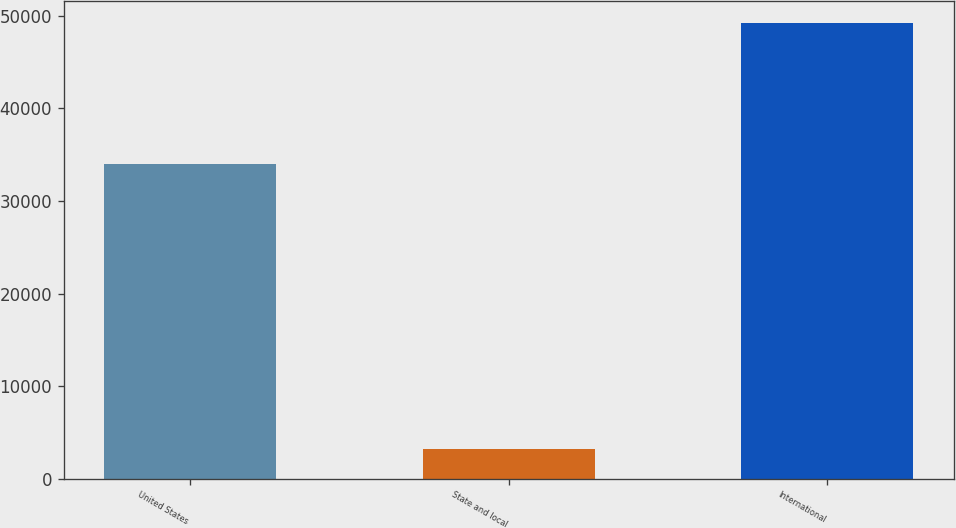Convert chart to OTSL. <chart><loc_0><loc_0><loc_500><loc_500><bar_chart><fcel>United States<fcel>State and local<fcel>International<nl><fcel>34049<fcel>3203<fcel>49200<nl></chart> 